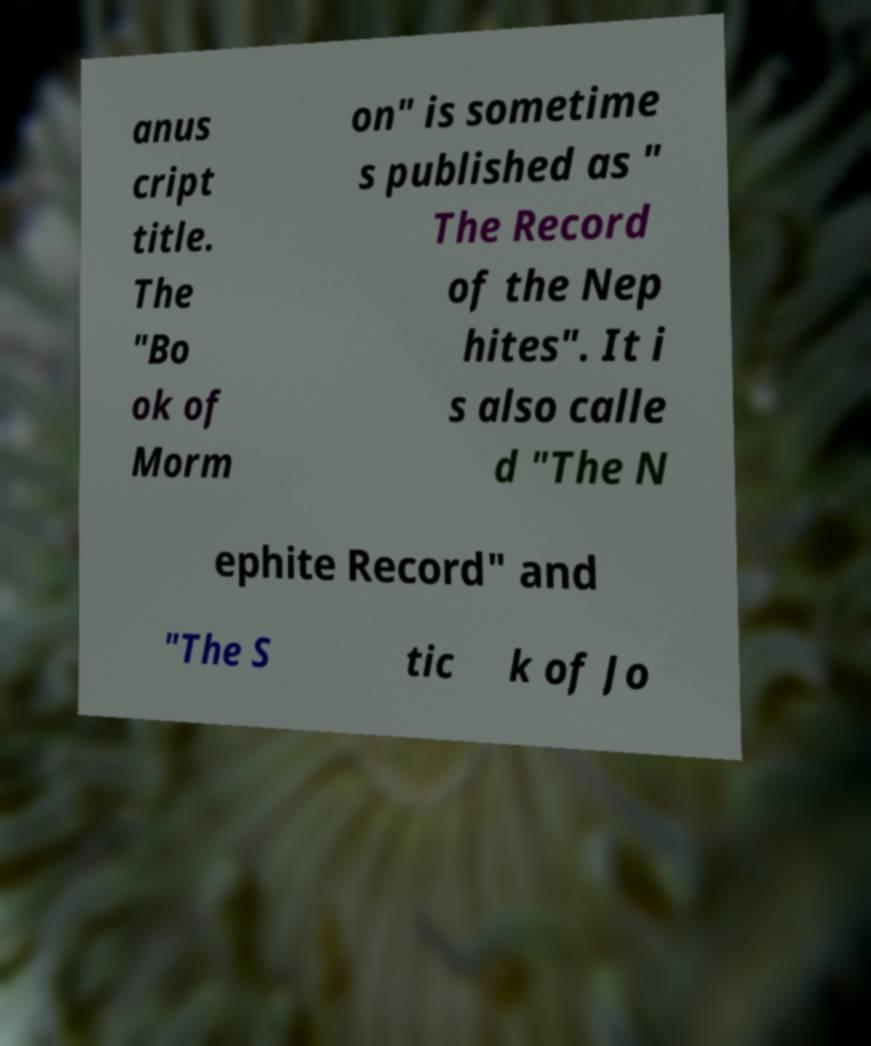I need the written content from this picture converted into text. Can you do that? anus cript title. The "Bo ok of Morm on" is sometime s published as " The Record of the Nep hites". It i s also calle d "The N ephite Record" and "The S tic k of Jo 